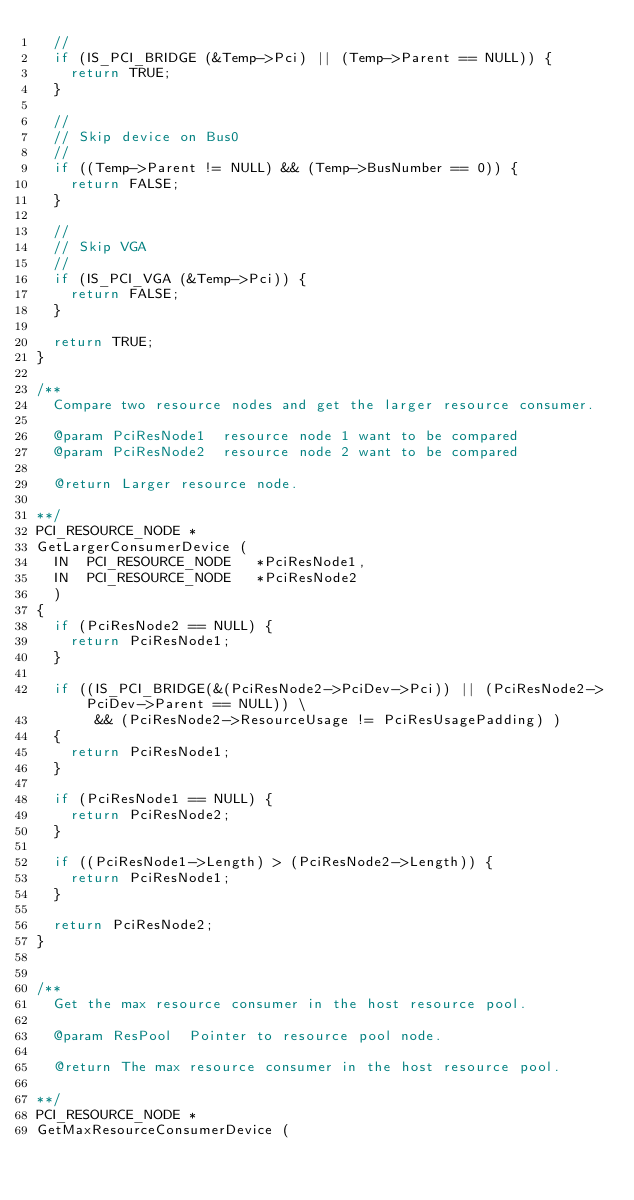Convert code to text. <code><loc_0><loc_0><loc_500><loc_500><_C_>  //
  if (IS_PCI_BRIDGE (&Temp->Pci) || (Temp->Parent == NULL)) {
    return TRUE;
  }

  //
  // Skip device on Bus0
  //
  if ((Temp->Parent != NULL) && (Temp->BusNumber == 0)) {
    return FALSE;
  }

  //
  // Skip VGA
  //
  if (IS_PCI_VGA (&Temp->Pci)) {
    return FALSE;
  }

  return TRUE;
}

/**
  Compare two resource nodes and get the larger resource consumer.

  @param PciResNode1  resource node 1 want to be compared
  @param PciResNode2  resource node 2 want to be compared

  @return Larger resource node.

**/
PCI_RESOURCE_NODE *
GetLargerConsumerDevice (
  IN  PCI_RESOURCE_NODE   *PciResNode1,
  IN  PCI_RESOURCE_NODE   *PciResNode2
  )
{
  if (PciResNode2 == NULL) {
    return PciResNode1;
  }

  if ((IS_PCI_BRIDGE(&(PciResNode2->PciDev->Pci)) || (PciResNode2->PciDev->Parent == NULL)) \
       && (PciResNode2->ResourceUsage != PciResUsagePadding) )
  {
    return PciResNode1;
  }

  if (PciResNode1 == NULL) {
    return PciResNode2;
  }

  if ((PciResNode1->Length) > (PciResNode2->Length)) {
    return PciResNode1;
  }

  return PciResNode2;
}


/**
  Get the max resource consumer in the host resource pool.

  @param ResPool  Pointer to resource pool node.

  @return The max resource consumer in the host resource pool.

**/
PCI_RESOURCE_NODE *
GetMaxResourceConsumerDevice (</code> 